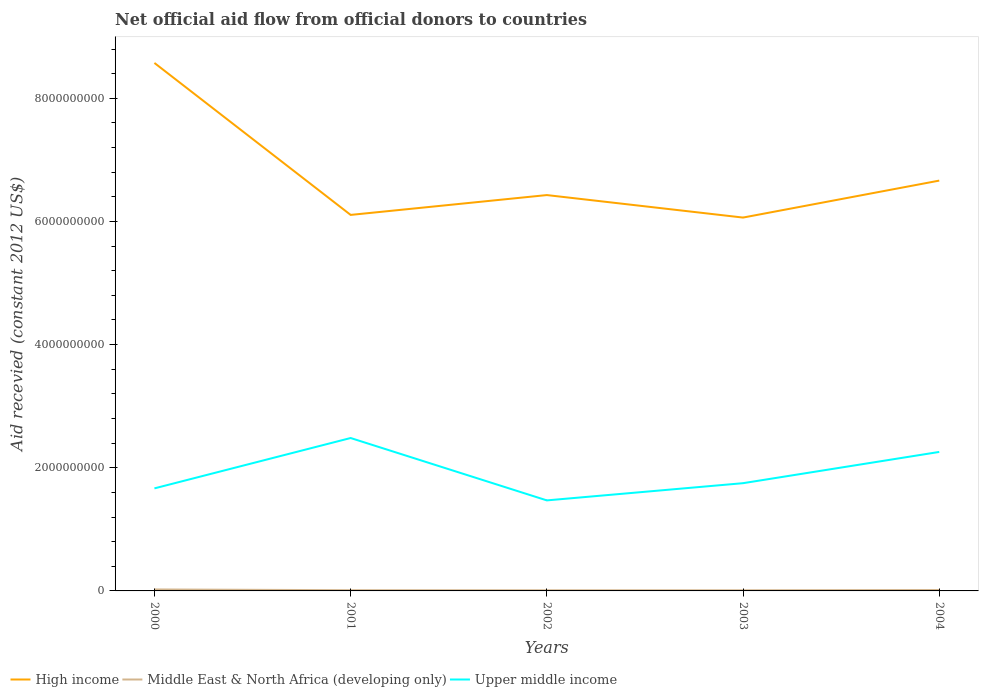Does the line corresponding to Middle East & North Africa (developing only) intersect with the line corresponding to Upper middle income?
Your answer should be compact. No. Is the number of lines equal to the number of legend labels?
Your response must be concise. Yes. Across all years, what is the maximum total aid received in High income?
Offer a terse response. 6.06e+09. What is the total total aid received in High income in the graph?
Give a very brief answer. 4.32e+07. What is the difference between the highest and the second highest total aid received in High income?
Give a very brief answer. 2.51e+09. Is the total aid received in High income strictly greater than the total aid received in Middle East & North Africa (developing only) over the years?
Provide a succinct answer. No. Are the values on the major ticks of Y-axis written in scientific E-notation?
Offer a terse response. No. Does the graph contain any zero values?
Give a very brief answer. No. Does the graph contain grids?
Ensure brevity in your answer.  No. How are the legend labels stacked?
Ensure brevity in your answer.  Horizontal. What is the title of the graph?
Your answer should be very brief. Net official aid flow from official donors to countries. What is the label or title of the X-axis?
Ensure brevity in your answer.  Years. What is the label or title of the Y-axis?
Provide a succinct answer. Aid recevied (constant 2012 US$). What is the Aid recevied (constant 2012 US$) of High income in 2000?
Offer a terse response. 8.57e+09. What is the Aid recevied (constant 2012 US$) in Middle East & North Africa (developing only) in 2000?
Provide a succinct answer. 2.38e+07. What is the Aid recevied (constant 2012 US$) in Upper middle income in 2000?
Ensure brevity in your answer.  1.67e+09. What is the Aid recevied (constant 2012 US$) in High income in 2001?
Your response must be concise. 6.11e+09. What is the Aid recevied (constant 2012 US$) in Middle East & North Africa (developing only) in 2001?
Make the answer very short. 1.17e+07. What is the Aid recevied (constant 2012 US$) of Upper middle income in 2001?
Your answer should be compact. 2.48e+09. What is the Aid recevied (constant 2012 US$) of High income in 2002?
Give a very brief answer. 6.43e+09. What is the Aid recevied (constant 2012 US$) of Middle East & North Africa (developing only) in 2002?
Keep it short and to the point. 1.05e+07. What is the Aid recevied (constant 2012 US$) of Upper middle income in 2002?
Provide a short and direct response. 1.47e+09. What is the Aid recevied (constant 2012 US$) of High income in 2003?
Make the answer very short. 6.06e+09. What is the Aid recevied (constant 2012 US$) in Middle East & North Africa (developing only) in 2003?
Provide a short and direct response. 1.03e+07. What is the Aid recevied (constant 2012 US$) in Upper middle income in 2003?
Your response must be concise. 1.75e+09. What is the Aid recevied (constant 2012 US$) of High income in 2004?
Provide a short and direct response. 6.66e+09. What is the Aid recevied (constant 2012 US$) of Middle East & North Africa (developing only) in 2004?
Your answer should be compact. 1.50e+07. What is the Aid recevied (constant 2012 US$) in Upper middle income in 2004?
Provide a succinct answer. 2.26e+09. Across all years, what is the maximum Aid recevied (constant 2012 US$) of High income?
Your response must be concise. 8.57e+09. Across all years, what is the maximum Aid recevied (constant 2012 US$) of Middle East & North Africa (developing only)?
Make the answer very short. 2.38e+07. Across all years, what is the maximum Aid recevied (constant 2012 US$) in Upper middle income?
Provide a succinct answer. 2.48e+09. Across all years, what is the minimum Aid recevied (constant 2012 US$) of High income?
Offer a very short reply. 6.06e+09. Across all years, what is the minimum Aid recevied (constant 2012 US$) in Middle East & North Africa (developing only)?
Make the answer very short. 1.03e+07. Across all years, what is the minimum Aid recevied (constant 2012 US$) in Upper middle income?
Provide a short and direct response. 1.47e+09. What is the total Aid recevied (constant 2012 US$) of High income in the graph?
Your answer should be very brief. 3.38e+1. What is the total Aid recevied (constant 2012 US$) in Middle East & North Africa (developing only) in the graph?
Give a very brief answer. 7.14e+07. What is the total Aid recevied (constant 2012 US$) in Upper middle income in the graph?
Keep it short and to the point. 9.62e+09. What is the difference between the Aid recevied (constant 2012 US$) of High income in 2000 and that in 2001?
Keep it short and to the point. 2.47e+09. What is the difference between the Aid recevied (constant 2012 US$) of Middle East & North Africa (developing only) in 2000 and that in 2001?
Your answer should be compact. 1.21e+07. What is the difference between the Aid recevied (constant 2012 US$) of Upper middle income in 2000 and that in 2001?
Make the answer very short. -8.18e+08. What is the difference between the Aid recevied (constant 2012 US$) in High income in 2000 and that in 2002?
Your response must be concise. 2.15e+09. What is the difference between the Aid recevied (constant 2012 US$) of Middle East & North Africa (developing only) in 2000 and that in 2002?
Offer a very short reply. 1.33e+07. What is the difference between the Aid recevied (constant 2012 US$) of Upper middle income in 2000 and that in 2002?
Give a very brief answer. 1.95e+08. What is the difference between the Aid recevied (constant 2012 US$) in High income in 2000 and that in 2003?
Make the answer very short. 2.51e+09. What is the difference between the Aid recevied (constant 2012 US$) in Middle East & North Africa (developing only) in 2000 and that in 2003?
Provide a succinct answer. 1.34e+07. What is the difference between the Aid recevied (constant 2012 US$) in Upper middle income in 2000 and that in 2003?
Your response must be concise. -8.44e+07. What is the difference between the Aid recevied (constant 2012 US$) in High income in 2000 and that in 2004?
Offer a very short reply. 1.91e+09. What is the difference between the Aid recevied (constant 2012 US$) in Middle East & North Africa (developing only) in 2000 and that in 2004?
Your answer should be very brief. 8.78e+06. What is the difference between the Aid recevied (constant 2012 US$) of Upper middle income in 2000 and that in 2004?
Offer a very short reply. -5.92e+08. What is the difference between the Aid recevied (constant 2012 US$) of High income in 2001 and that in 2002?
Give a very brief answer. -3.22e+08. What is the difference between the Aid recevied (constant 2012 US$) in Middle East & North Africa (developing only) in 2001 and that in 2002?
Offer a terse response. 1.22e+06. What is the difference between the Aid recevied (constant 2012 US$) in Upper middle income in 2001 and that in 2002?
Provide a succinct answer. 1.01e+09. What is the difference between the Aid recevied (constant 2012 US$) of High income in 2001 and that in 2003?
Your answer should be compact. 4.32e+07. What is the difference between the Aid recevied (constant 2012 US$) in Middle East & North Africa (developing only) in 2001 and that in 2003?
Make the answer very short. 1.39e+06. What is the difference between the Aid recevied (constant 2012 US$) in Upper middle income in 2001 and that in 2003?
Offer a very short reply. 7.33e+08. What is the difference between the Aid recevied (constant 2012 US$) of High income in 2001 and that in 2004?
Offer a terse response. -5.57e+08. What is the difference between the Aid recevied (constant 2012 US$) of Middle East & North Africa (developing only) in 2001 and that in 2004?
Offer a terse response. -3.28e+06. What is the difference between the Aid recevied (constant 2012 US$) of Upper middle income in 2001 and that in 2004?
Make the answer very short. 2.26e+08. What is the difference between the Aid recevied (constant 2012 US$) of High income in 2002 and that in 2003?
Provide a succinct answer. 3.65e+08. What is the difference between the Aid recevied (constant 2012 US$) of Middle East & North Africa (developing only) in 2002 and that in 2003?
Provide a succinct answer. 1.70e+05. What is the difference between the Aid recevied (constant 2012 US$) of Upper middle income in 2002 and that in 2003?
Offer a terse response. -2.79e+08. What is the difference between the Aid recevied (constant 2012 US$) in High income in 2002 and that in 2004?
Give a very brief answer. -2.35e+08. What is the difference between the Aid recevied (constant 2012 US$) in Middle East & North Africa (developing only) in 2002 and that in 2004?
Your answer should be compact. -4.50e+06. What is the difference between the Aid recevied (constant 2012 US$) of Upper middle income in 2002 and that in 2004?
Your answer should be very brief. -7.87e+08. What is the difference between the Aid recevied (constant 2012 US$) in High income in 2003 and that in 2004?
Offer a terse response. -6.00e+08. What is the difference between the Aid recevied (constant 2012 US$) in Middle East & North Africa (developing only) in 2003 and that in 2004?
Give a very brief answer. -4.67e+06. What is the difference between the Aid recevied (constant 2012 US$) in Upper middle income in 2003 and that in 2004?
Your response must be concise. -5.07e+08. What is the difference between the Aid recevied (constant 2012 US$) of High income in 2000 and the Aid recevied (constant 2012 US$) of Middle East & North Africa (developing only) in 2001?
Offer a terse response. 8.56e+09. What is the difference between the Aid recevied (constant 2012 US$) in High income in 2000 and the Aid recevied (constant 2012 US$) in Upper middle income in 2001?
Provide a succinct answer. 6.09e+09. What is the difference between the Aid recevied (constant 2012 US$) of Middle East & North Africa (developing only) in 2000 and the Aid recevied (constant 2012 US$) of Upper middle income in 2001?
Offer a terse response. -2.46e+09. What is the difference between the Aid recevied (constant 2012 US$) in High income in 2000 and the Aid recevied (constant 2012 US$) in Middle East & North Africa (developing only) in 2002?
Give a very brief answer. 8.56e+09. What is the difference between the Aid recevied (constant 2012 US$) in High income in 2000 and the Aid recevied (constant 2012 US$) in Upper middle income in 2002?
Give a very brief answer. 7.10e+09. What is the difference between the Aid recevied (constant 2012 US$) in Middle East & North Africa (developing only) in 2000 and the Aid recevied (constant 2012 US$) in Upper middle income in 2002?
Give a very brief answer. -1.45e+09. What is the difference between the Aid recevied (constant 2012 US$) of High income in 2000 and the Aid recevied (constant 2012 US$) of Middle East & North Africa (developing only) in 2003?
Keep it short and to the point. 8.56e+09. What is the difference between the Aid recevied (constant 2012 US$) of High income in 2000 and the Aid recevied (constant 2012 US$) of Upper middle income in 2003?
Keep it short and to the point. 6.82e+09. What is the difference between the Aid recevied (constant 2012 US$) of Middle East & North Africa (developing only) in 2000 and the Aid recevied (constant 2012 US$) of Upper middle income in 2003?
Ensure brevity in your answer.  -1.73e+09. What is the difference between the Aid recevied (constant 2012 US$) in High income in 2000 and the Aid recevied (constant 2012 US$) in Middle East & North Africa (developing only) in 2004?
Your response must be concise. 8.56e+09. What is the difference between the Aid recevied (constant 2012 US$) in High income in 2000 and the Aid recevied (constant 2012 US$) in Upper middle income in 2004?
Provide a short and direct response. 6.32e+09. What is the difference between the Aid recevied (constant 2012 US$) of Middle East & North Africa (developing only) in 2000 and the Aid recevied (constant 2012 US$) of Upper middle income in 2004?
Your answer should be very brief. -2.23e+09. What is the difference between the Aid recevied (constant 2012 US$) in High income in 2001 and the Aid recevied (constant 2012 US$) in Middle East & North Africa (developing only) in 2002?
Your answer should be compact. 6.10e+09. What is the difference between the Aid recevied (constant 2012 US$) in High income in 2001 and the Aid recevied (constant 2012 US$) in Upper middle income in 2002?
Offer a very short reply. 4.64e+09. What is the difference between the Aid recevied (constant 2012 US$) in Middle East & North Africa (developing only) in 2001 and the Aid recevied (constant 2012 US$) in Upper middle income in 2002?
Keep it short and to the point. -1.46e+09. What is the difference between the Aid recevied (constant 2012 US$) in High income in 2001 and the Aid recevied (constant 2012 US$) in Middle East & North Africa (developing only) in 2003?
Provide a succinct answer. 6.10e+09. What is the difference between the Aid recevied (constant 2012 US$) in High income in 2001 and the Aid recevied (constant 2012 US$) in Upper middle income in 2003?
Your response must be concise. 4.36e+09. What is the difference between the Aid recevied (constant 2012 US$) in Middle East & North Africa (developing only) in 2001 and the Aid recevied (constant 2012 US$) in Upper middle income in 2003?
Your response must be concise. -1.74e+09. What is the difference between the Aid recevied (constant 2012 US$) of High income in 2001 and the Aid recevied (constant 2012 US$) of Middle East & North Africa (developing only) in 2004?
Provide a short and direct response. 6.09e+09. What is the difference between the Aid recevied (constant 2012 US$) in High income in 2001 and the Aid recevied (constant 2012 US$) in Upper middle income in 2004?
Your answer should be compact. 3.85e+09. What is the difference between the Aid recevied (constant 2012 US$) of Middle East & North Africa (developing only) in 2001 and the Aid recevied (constant 2012 US$) of Upper middle income in 2004?
Offer a terse response. -2.25e+09. What is the difference between the Aid recevied (constant 2012 US$) of High income in 2002 and the Aid recevied (constant 2012 US$) of Middle East & North Africa (developing only) in 2003?
Your answer should be compact. 6.42e+09. What is the difference between the Aid recevied (constant 2012 US$) in High income in 2002 and the Aid recevied (constant 2012 US$) in Upper middle income in 2003?
Your answer should be very brief. 4.68e+09. What is the difference between the Aid recevied (constant 2012 US$) of Middle East & North Africa (developing only) in 2002 and the Aid recevied (constant 2012 US$) of Upper middle income in 2003?
Ensure brevity in your answer.  -1.74e+09. What is the difference between the Aid recevied (constant 2012 US$) of High income in 2002 and the Aid recevied (constant 2012 US$) of Middle East & North Africa (developing only) in 2004?
Provide a succinct answer. 6.41e+09. What is the difference between the Aid recevied (constant 2012 US$) in High income in 2002 and the Aid recevied (constant 2012 US$) in Upper middle income in 2004?
Make the answer very short. 4.17e+09. What is the difference between the Aid recevied (constant 2012 US$) of Middle East & North Africa (developing only) in 2002 and the Aid recevied (constant 2012 US$) of Upper middle income in 2004?
Ensure brevity in your answer.  -2.25e+09. What is the difference between the Aid recevied (constant 2012 US$) of High income in 2003 and the Aid recevied (constant 2012 US$) of Middle East & North Africa (developing only) in 2004?
Keep it short and to the point. 6.05e+09. What is the difference between the Aid recevied (constant 2012 US$) in High income in 2003 and the Aid recevied (constant 2012 US$) in Upper middle income in 2004?
Make the answer very short. 3.81e+09. What is the difference between the Aid recevied (constant 2012 US$) in Middle East & North Africa (developing only) in 2003 and the Aid recevied (constant 2012 US$) in Upper middle income in 2004?
Offer a very short reply. -2.25e+09. What is the average Aid recevied (constant 2012 US$) of High income per year?
Keep it short and to the point. 6.77e+09. What is the average Aid recevied (constant 2012 US$) of Middle East & North Africa (developing only) per year?
Your answer should be very brief. 1.43e+07. What is the average Aid recevied (constant 2012 US$) in Upper middle income per year?
Give a very brief answer. 1.92e+09. In the year 2000, what is the difference between the Aid recevied (constant 2012 US$) of High income and Aid recevied (constant 2012 US$) of Middle East & North Africa (developing only)?
Ensure brevity in your answer.  8.55e+09. In the year 2000, what is the difference between the Aid recevied (constant 2012 US$) in High income and Aid recevied (constant 2012 US$) in Upper middle income?
Keep it short and to the point. 6.91e+09. In the year 2000, what is the difference between the Aid recevied (constant 2012 US$) in Middle East & North Africa (developing only) and Aid recevied (constant 2012 US$) in Upper middle income?
Offer a terse response. -1.64e+09. In the year 2001, what is the difference between the Aid recevied (constant 2012 US$) of High income and Aid recevied (constant 2012 US$) of Middle East & North Africa (developing only)?
Your response must be concise. 6.09e+09. In the year 2001, what is the difference between the Aid recevied (constant 2012 US$) of High income and Aid recevied (constant 2012 US$) of Upper middle income?
Make the answer very short. 3.62e+09. In the year 2001, what is the difference between the Aid recevied (constant 2012 US$) in Middle East & North Africa (developing only) and Aid recevied (constant 2012 US$) in Upper middle income?
Your answer should be very brief. -2.47e+09. In the year 2002, what is the difference between the Aid recevied (constant 2012 US$) of High income and Aid recevied (constant 2012 US$) of Middle East & North Africa (developing only)?
Your answer should be very brief. 6.42e+09. In the year 2002, what is the difference between the Aid recevied (constant 2012 US$) of High income and Aid recevied (constant 2012 US$) of Upper middle income?
Give a very brief answer. 4.96e+09. In the year 2002, what is the difference between the Aid recevied (constant 2012 US$) in Middle East & North Africa (developing only) and Aid recevied (constant 2012 US$) in Upper middle income?
Ensure brevity in your answer.  -1.46e+09. In the year 2003, what is the difference between the Aid recevied (constant 2012 US$) in High income and Aid recevied (constant 2012 US$) in Middle East & North Africa (developing only)?
Provide a short and direct response. 6.05e+09. In the year 2003, what is the difference between the Aid recevied (constant 2012 US$) in High income and Aid recevied (constant 2012 US$) in Upper middle income?
Ensure brevity in your answer.  4.31e+09. In the year 2003, what is the difference between the Aid recevied (constant 2012 US$) of Middle East & North Africa (developing only) and Aid recevied (constant 2012 US$) of Upper middle income?
Your answer should be very brief. -1.74e+09. In the year 2004, what is the difference between the Aid recevied (constant 2012 US$) in High income and Aid recevied (constant 2012 US$) in Middle East & North Africa (developing only)?
Keep it short and to the point. 6.65e+09. In the year 2004, what is the difference between the Aid recevied (constant 2012 US$) in High income and Aid recevied (constant 2012 US$) in Upper middle income?
Your response must be concise. 4.41e+09. In the year 2004, what is the difference between the Aid recevied (constant 2012 US$) in Middle East & North Africa (developing only) and Aid recevied (constant 2012 US$) in Upper middle income?
Ensure brevity in your answer.  -2.24e+09. What is the ratio of the Aid recevied (constant 2012 US$) of High income in 2000 to that in 2001?
Provide a short and direct response. 1.4. What is the ratio of the Aid recevied (constant 2012 US$) of Middle East & North Africa (developing only) in 2000 to that in 2001?
Offer a very short reply. 2.03. What is the ratio of the Aid recevied (constant 2012 US$) of Upper middle income in 2000 to that in 2001?
Provide a succinct answer. 0.67. What is the ratio of the Aid recevied (constant 2012 US$) in High income in 2000 to that in 2002?
Provide a short and direct response. 1.33. What is the ratio of the Aid recevied (constant 2012 US$) of Middle East & North Africa (developing only) in 2000 to that in 2002?
Your response must be concise. 2.26. What is the ratio of the Aid recevied (constant 2012 US$) in Upper middle income in 2000 to that in 2002?
Your response must be concise. 1.13. What is the ratio of the Aid recevied (constant 2012 US$) in High income in 2000 to that in 2003?
Offer a very short reply. 1.41. What is the ratio of the Aid recevied (constant 2012 US$) of Middle East & North Africa (developing only) in 2000 to that in 2003?
Offer a very short reply. 2.3. What is the ratio of the Aid recevied (constant 2012 US$) of Upper middle income in 2000 to that in 2003?
Keep it short and to the point. 0.95. What is the ratio of the Aid recevied (constant 2012 US$) in High income in 2000 to that in 2004?
Offer a very short reply. 1.29. What is the ratio of the Aid recevied (constant 2012 US$) of Middle East & North Africa (developing only) in 2000 to that in 2004?
Offer a very short reply. 1.58. What is the ratio of the Aid recevied (constant 2012 US$) in Upper middle income in 2000 to that in 2004?
Your answer should be compact. 0.74. What is the ratio of the Aid recevied (constant 2012 US$) of High income in 2001 to that in 2002?
Your response must be concise. 0.95. What is the ratio of the Aid recevied (constant 2012 US$) in Middle East & North Africa (developing only) in 2001 to that in 2002?
Your answer should be compact. 1.12. What is the ratio of the Aid recevied (constant 2012 US$) of Upper middle income in 2001 to that in 2002?
Make the answer very short. 1.69. What is the ratio of the Aid recevied (constant 2012 US$) in High income in 2001 to that in 2003?
Offer a terse response. 1.01. What is the ratio of the Aid recevied (constant 2012 US$) in Middle East & North Africa (developing only) in 2001 to that in 2003?
Make the answer very short. 1.13. What is the ratio of the Aid recevied (constant 2012 US$) in Upper middle income in 2001 to that in 2003?
Your answer should be very brief. 1.42. What is the ratio of the Aid recevied (constant 2012 US$) in High income in 2001 to that in 2004?
Provide a short and direct response. 0.92. What is the ratio of the Aid recevied (constant 2012 US$) of Middle East & North Africa (developing only) in 2001 to that in 2004?
Ensure brevity in your answer.  0.78. What is the ratio of the Aid recevied (constant 2012 US$) in Upper middle income in 2001 to that in 2004?
Ensure brevity in your answer.  1.1. What is the ratio of the Aid recevied (constant 2012 US$) of High income in 2002 to that in 2003?
Ensure brevity in your answer.  1.06. What is the ratio of the Aid recevied (constant 2012 US$) in Middle East & North Africa (developing only) in 2002 to that in 2003?
Ensure brevity in your answer.  1.02. What is the ratio of the Aid recevied (constant 2012 US$) in Upper middle income in 2002 to that in 2003?
Offer a very short reply. 0.84. What is the ratio of the Aid recevied (constant 2012 US$) of High income in 2002 to that in 2004?
Your answer should be very brief. 0.96. What is the ratio of the Aid recevied (constant 2012 US$) in Middle East & North Africa (developing only) in 2002 to that in 2004?
Give a very brief answer. 0.7. What is the ratio of the Aid recevied (constant 2012 US$) in Upper middle income in 2002 to that in 2004?
Give a very brief answer. 0.65. What is the ratio of the Aid recevied (constant 2012 US$) in High income in 2003 to that in 2004?
Your answer should be very brief. 0.91. What is the ratio of the Aid recevied (constant 2012 US$) of Middle East & North Africa (developing only) in 2003 to that in 2004?
Offer a very short reply. 0.69. What is the ratio of the Aid recevied (constant 2012 US$) in Upper middle income in 2003 to that in 2004?
Your answer should be very brief. 0.78. What is the difference between the highest and the second highest Aid recevied (constant 2012 US$) of High income?
Make the answer very short. 1.91e+09. What is the difference between the highest and the second highest Aid recevied (constant 2012 US$) in Middle East & North Africa (developing only)?
Offer a very short reply. 8.78e+06. What is the difference between the highest and the second highest Aid recevied (constant 2012 US$) of Upper middle income?
Provide a short and direct response. 2.26e+08. What is the difference between the highest and the lowest Aid recevied (constant 2012 US$) of High income?
Offer a very short reply. 2.51e+09. What is the difference between the highest and the lowest Aid recevied (constant 2012 US$) in Middle East & North Africa (developing only)?
Your answer should be very brief. 1.34e+07. What is the difference between the highest and the lowest Aid recevied (constant 2012 US$) of Upper middle income?
Provide a succinct answer. 1.01e+09. 